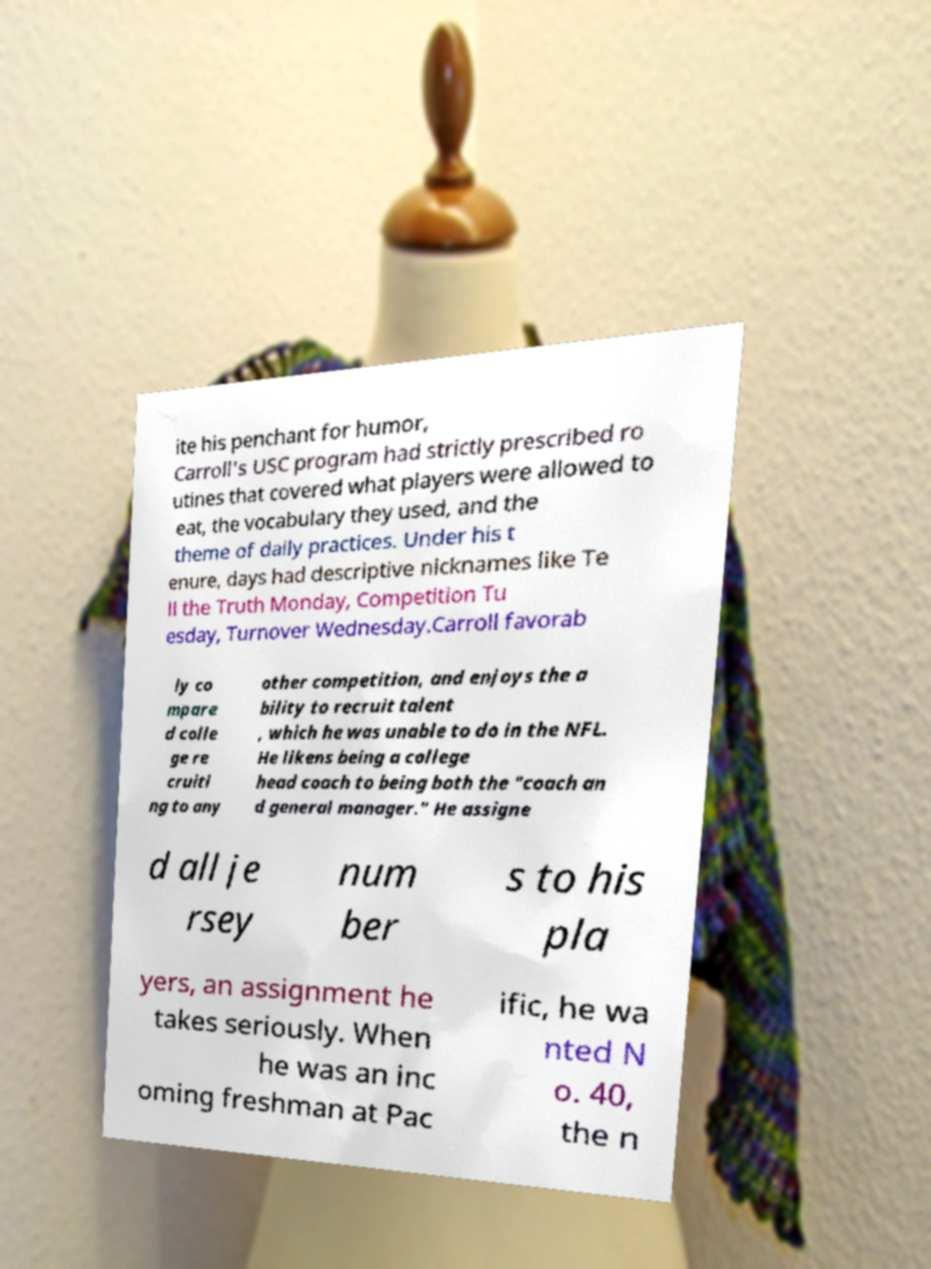There's text embedded in this image that I need extracted. Can you transcribe it verbatim? ite his penchant for humor, Carroll's USC program had strictly prescribed ro utines that covered what players were allowed to eat, the vocabulary they used, and the theme of daily practices. Under his t enure, days had descriptive nicknames like Te ll the Truth Monday, Competition Tu esday, Turnover Wednesday.Carroll favorab ly co mpare d colle ge re cruiti ng to any other competition, and enjoys the a bility to recruit talent , which he was unable to do in the NFL. He likens being a college head coach to being both the "coach an d general manager." He assigne d all je rsey num ber s to his pla yers, an assignment he takes seriously. When he was an inc oming freshman at Pac ific, he wa nted N o. 40, the n 